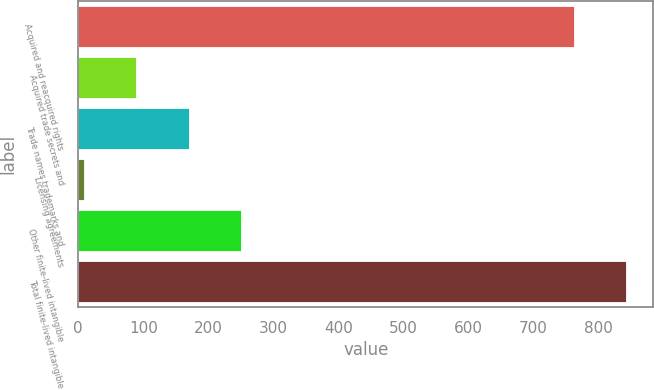Convert chart. <chart><loc_0><loc_0><loc_500><loc_500><bar_chart><fcel>Acquired and reacquired rights<fcel>Acquired trade secrets and<fcel>Trade names trademarks and<fcel>Licensing agreements<fcel>Other finite-lived intangible<fcel>Total finite-lived intangible<nl><fcel>761.6<fcel>89.4<fcel>169.6<fcel>9.2<fcel>249.8<fcel>841.8<nl></chart> 